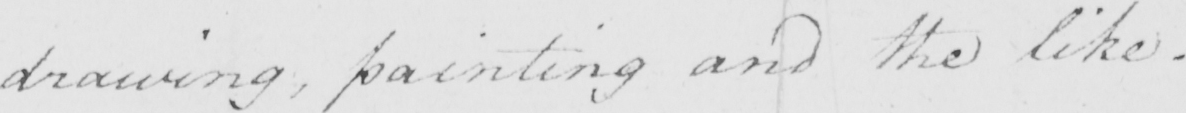What is written in this line of handwriting? drawing , painting and the like . 